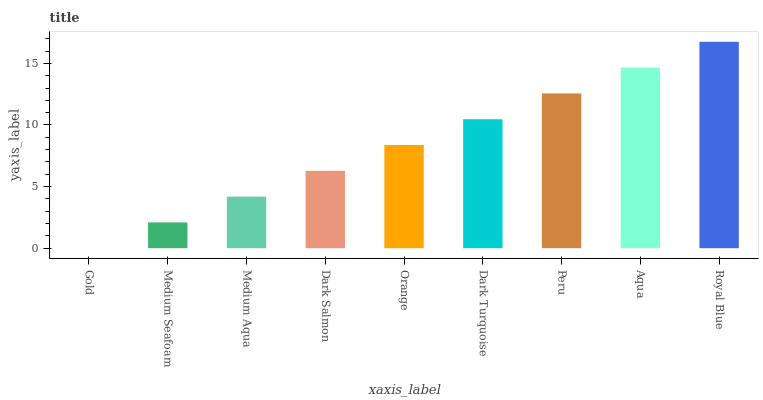Is Gold the minimum?
Answer yes or no. Yes. Is Royal Blue the maximum?
Answer yes or no. Yes. Is Medium Seafoam the minimum?
Answer yes or no. No. Is Medium Seafoam the maximum?
Answer yes or no. No. Is Medium Seafoam greater than Gold?
Answer yes or no. Yes. Is Gold less than Medium Seafoam?
Answer yes or no. Yes. Is Gold greater than Medium Seafoam?
Answer yes or no. No. Is Medium Seafoam less than Gold?
Answer yes or no. No. Is Orange the high median?
Answer yes or no. Yes. Is Orange the low median?
Answer yes or no. Yes. Is Royal Blue the high median?
Answer yes or no. No. Is Medium Aqua the low median?
Answer yes or no. No. 